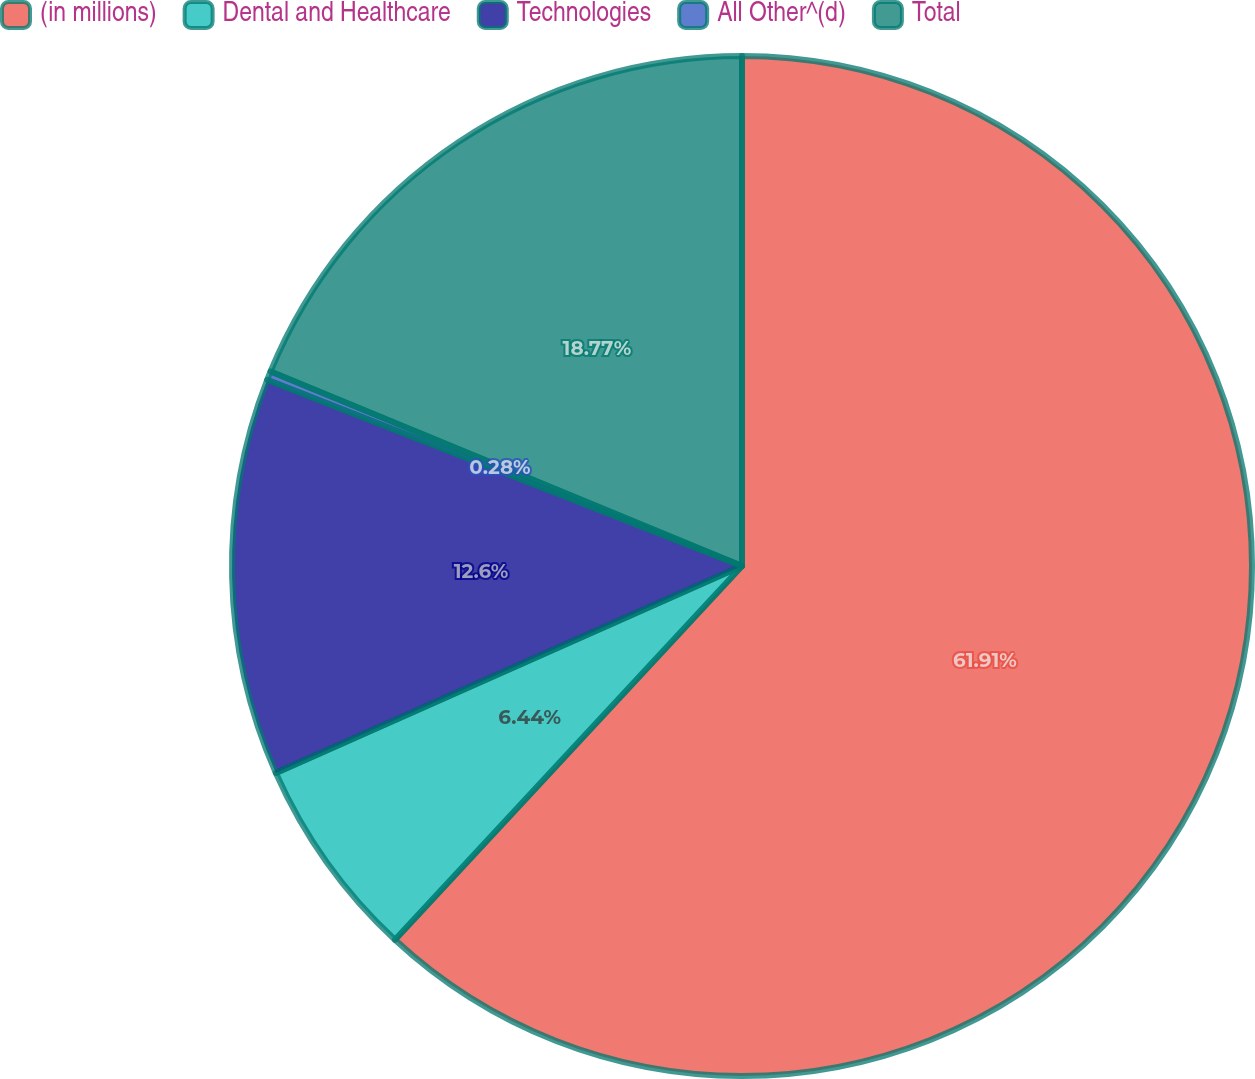Convert chart to OTSL. <chart><loc_0><loc_0><loc_500><loc_500><pie_chart><fcel>(in millions)<fcel>Dental and Healthcare<fcel>Technologies<fcel>All Other^(d)<fcel>Total<nl><fcel>61.91%<fcel>6.44%<fcel>12.6%<fcel>0.28%<fcel>18.77%<nl></chart> 